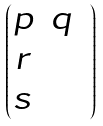Convert formula to latex. <formula><loc_0><loc_0><loc_500><loc_500>\begin{pmatrix} p & q & \\ r & & \\ s & & \end{pmatrix}</formula> 